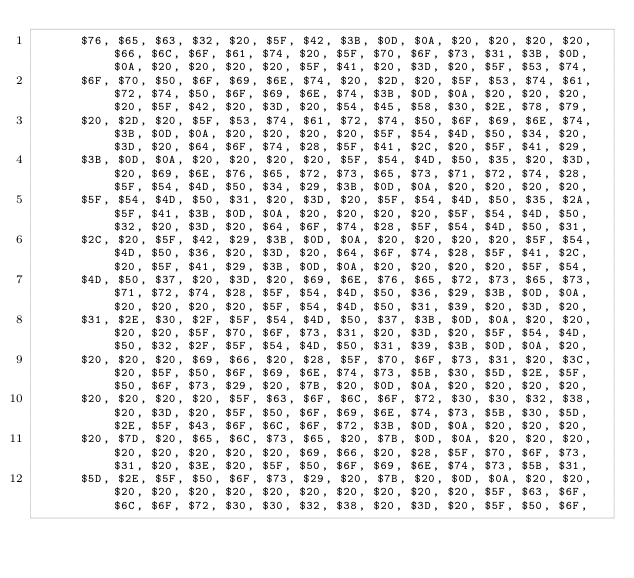<code> <loc_0><loc_0><loc_500><loc_500><_Pascal_>      $76, $65, $63, $32, $20, $5F, $42, $3B, $0D, $0A, $20, $20, $20, $20, $66, $6C, $6F, $61, $74, $20, $5F, $70, $6F, $73, $31, $3B, $0D, $0A, $20, $20, $20, $20, $5F, $41, $20, $3D, $20, $5F, $53, $74,
      $6F, $70, $50, $6F, $69, $6E, $74, $20, $2D, $20, $5F, $53, $74, $61, $72, $74, $50, $6F, $69, $6E, $74, $3B, $0D, $0A, $20, $20, $20, $20, $5F, $42, $20, $3D, $20, $54, $45, $58, $30, $2E, $78, $79,
      $20, $2D, $20, $5F, $53, $74, $61, $72, $74, $50, $6F, $69, $6E, $74, $3B, $0D, $0A, $20, $20, $20, $20, $5F, $54, $4D, $50, $34, $20, $3D, $20, $64, $6F, $74, $28, $5F, $41, $2C, $20, $5F, $41, $29,
      $3B, $0D, $0A, $20, $20, $20, $20, $5F, $54, $4D, $50, $35, $20, $3D, $20, $69, $6E, $76, $65, $72, $73, $65, $73, $71, $72, $74, $28, $5F, $54, $4D, $50, $34, $29, $3B, $0D, $0A, $20, $20, $20, $20,
      $5F, $54, $4D, $50, $31, $20, $3D, $20, $5F, $54, $4D, $50, $35, $2A, $5F, $41, $3B, $0D, $0A, $20, $20, $20, $20, $5F, $54, $4D, $50, $32, $20, $3D, $20, $64, $6F, $74, $28, $5F, $54, $4D, $50, $31,
      $2C, $20, $5F, $42, $29, $3B, $0D, $0A, $20, $20, $20, $20, $5F, $54, $4D, $50, $36, $20, $3D, $20, $64, $6F, $74, $28, $5F, $41, $2C, $20, $5F, $41, $29, $3B, $0D, $0A, $20, $20, $20, $20, $5F, $54,
      $4D, $50, $37, $20, $3D, $20, $69, $6E, $76, $65, $72, $73, $65, $73, $71, $72, $74, $28, $5F, $54, $4D, $50, $36, $29, $3B, $0D, $0A, $20, $20, $20, $20, $5F, $54, $4D, $50, $31, $39, $20, $3D, $20,
      $31, $2E, $30, $2F, $5F, $54, $4D, $50, $37, $3B, $0D, $0A, $20, $20, $20, $20, $5F, $70, $6F, $73, $31, $20, $3D, $20, $5F, $54, $4D, $50, $32, $2F, $5F, $54, $4D, $50, $31, $39, $3B, $0D, $0A, $20,
      $20, $20, $20, $69, $66, $20, $28, $5F, $70, $6F, $73, $31, $20, $3C, $20, $5F, $50, $6F, $69, $6E, $74, $73, $5B, $30, $5D, $2E, $5F, $50, $6F, $73, $29, $20, $7B, $20, $0D, $0A, $20, $20, $20, $20,
      $20, $20, $20, $20, $5F, $63, $6F, $6C, $6F, $72, $30, $30, $32, $38, $20, $3D, $20, $5F, $50, $6F, $69, $6E, $74, $73, $5B, $30, $5D, $2E, $5F, $43, $6F, $6C, $6F, $72, $3B, $0D, $0A, $20, $20, $20,
      $20, $7D, $20, $65, $6C, $73, $65, $20, $7B, $0D, $0A, $20, $20, $20, $20, $20, $20, $20, $20, $69, $66, $20, $28, $5F, $70, $6F, $73, $31, $20, $3E, $20, $5F, $50, $6F, $69, $6E, $74, $73, $5B, $31,
      $5D, $2E, $5F, $50, $6F, $73, $29, $20, $7B, $20, $0D, $0A, $20, $20, $20, $20, $20, $20, $20, $20, $20, $20, $20, $20, $5F, $63, $6F, $6C, $6F, $72, $30, $30, $32, $38, $20, $3D, $20, $5F, $50, $6F,</code> 